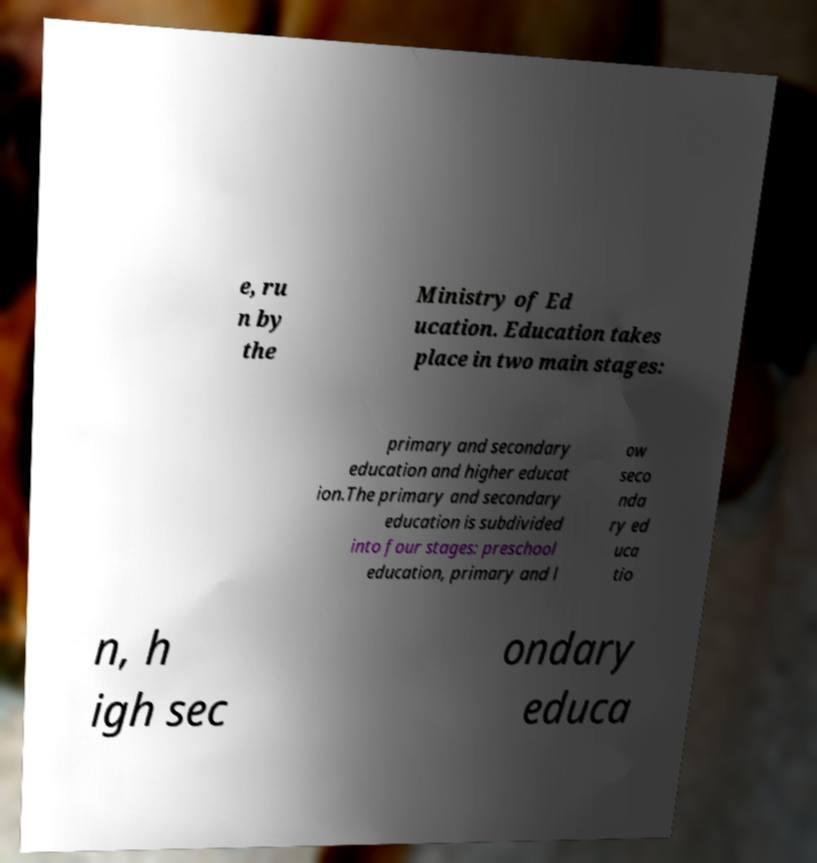What messages or text are displayed in this image? I need them in a readable, typed format. e, ru n by the Ministry of Ed ucation. Education takes place in two main stages: primary and secondary education and higher educat ion.The primary and secondary education is subdivided into four stages: preschool education, primary and l ow seco nda ry ed uca tio n, h igh sec ondary educa 